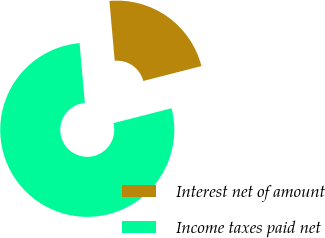Convert chart. <chart><loc_0><loc_0><loc_500><loc_500><pie_chart><fcel>Interest net of amount<fcel>Income taxes paid net<nl><fcel>22.42%<fcel>77.58%<nl></chart> 